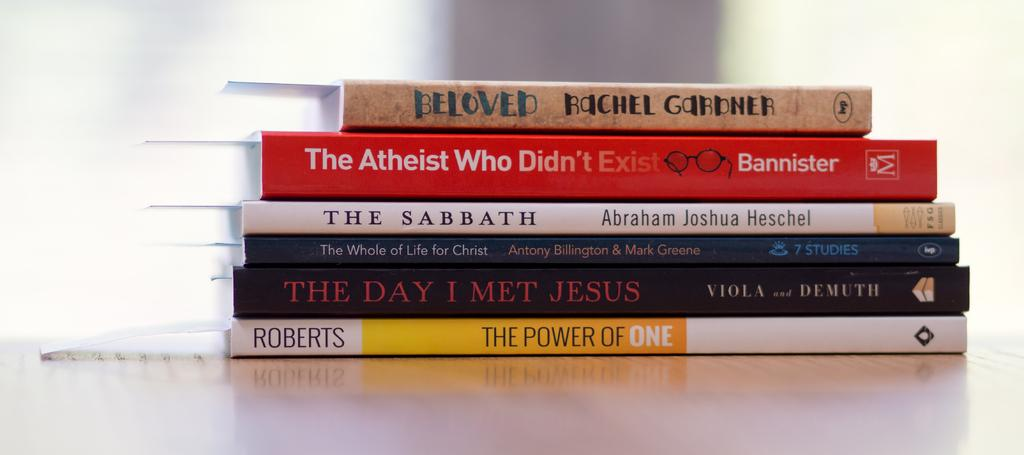<image>
Give a short and clear explanation of the subsequent image. stacked up books on a table include Beloved and The Sabbath 